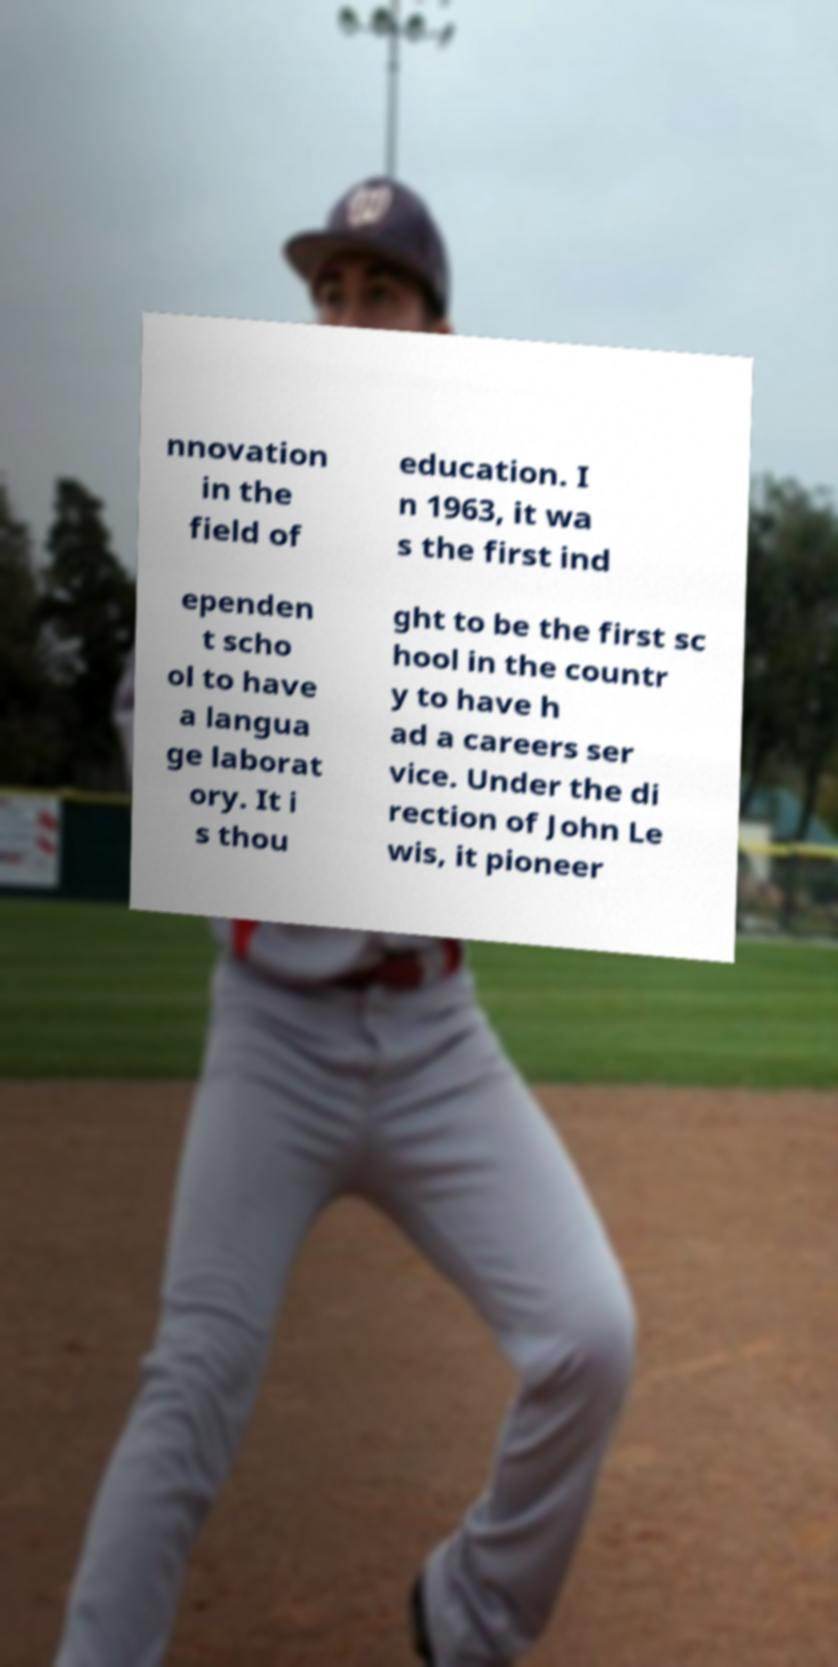There's text embedded in this image that I need extracted. Can you transcribe it verbatim? nnovation in the field of education. I n 1963, it wa s the first ind ependen t scho ol to have a langua ge laborat ory. It i s thou ght to be the first sc hool in the countr y to have h ad a careers ser vice. Under the di rection of John Le wis, it pioneer 